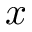<formula> <loc_0><loc_0><loc_500><loc_500>x</formula> 